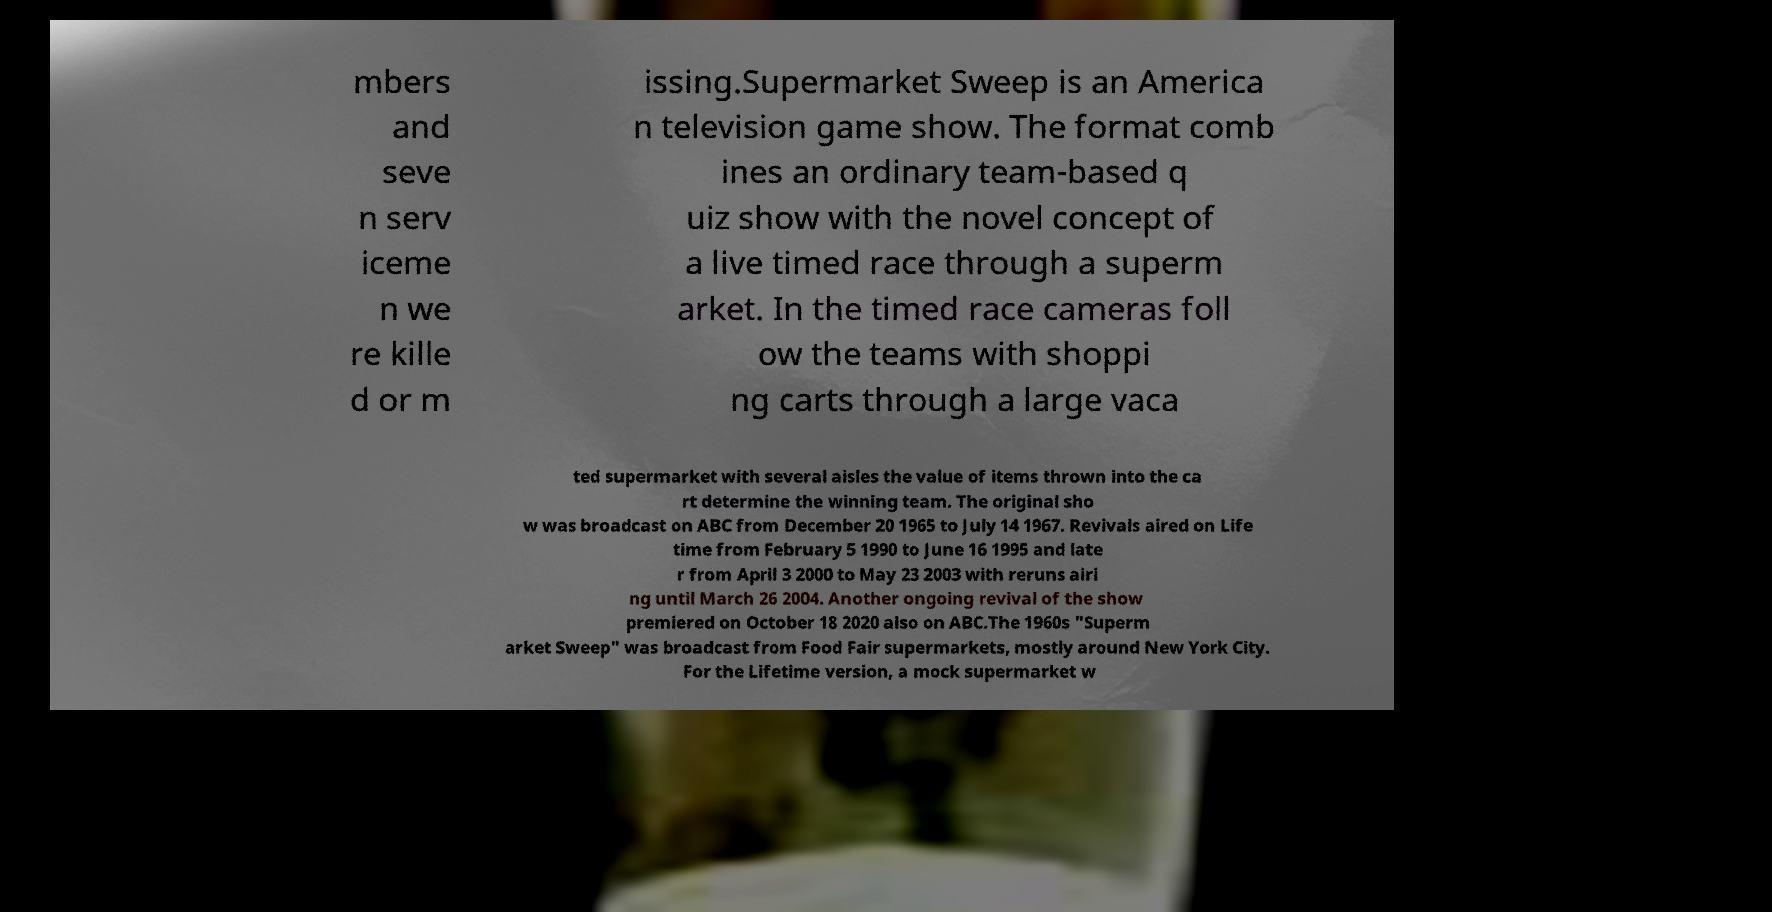Can you accurately transcribe the text from the provided image for me? mbers and seve n serv iceme n we re kille d or m issing.Supermarket Sweep is an America n television game show. The format comb ines an ordinary team-based q uiz show with the novel concept of a live timed race through a superm arket. In the timed race cameras foll ow the teams with shoppi ng carts through a large vaca ted supermarket with several aisles the value of items thrown into the ca rt determine the winning team. The original sho w was broadcast on ABC from December 20 1965 to July 14 1967. Revivals aired on Life time from February 5 1990 to June 16 1995 and late r from April 3 2000 to May 23 2003 with reruns airi ng until March 26 2004. Another ongoing revival of the show premiered on October 18 2020 also on ABC.The 1960s "Superm arket Sweep" was broadcast from Food Fair supermarkets, mostly around New York City. For the Lifetime version, a mock supermarket w 